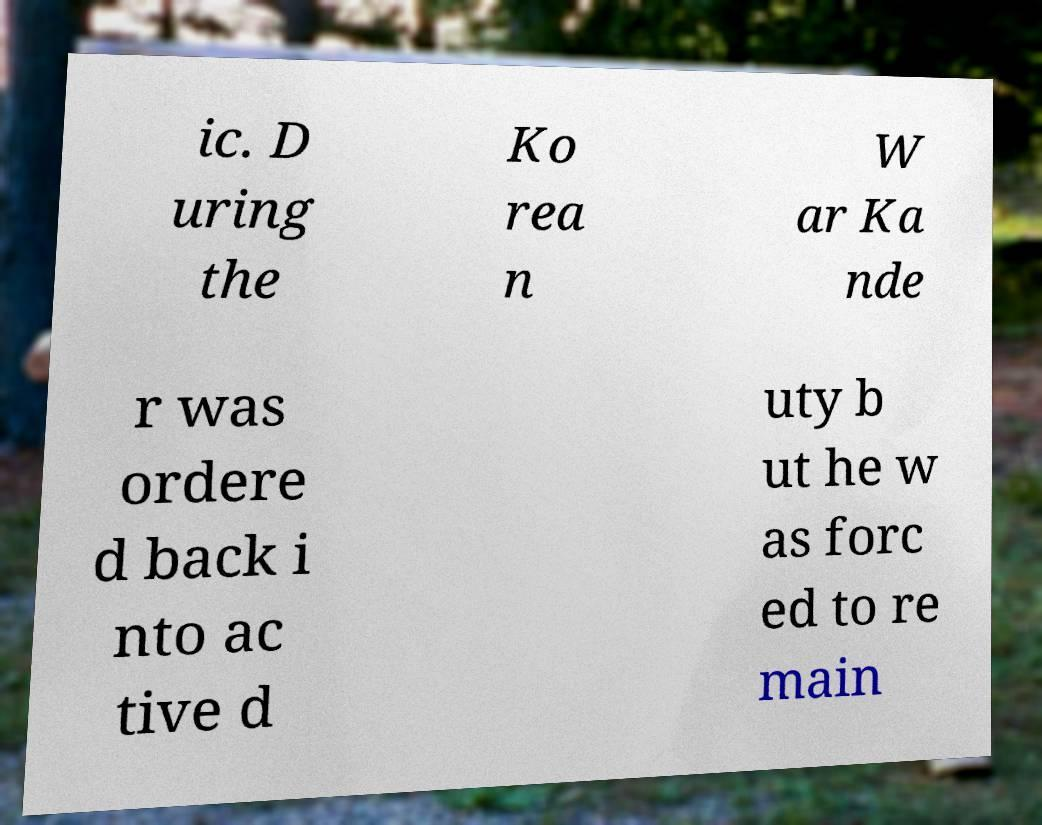Can you read and provide the text displayed in the image?This photo seems to have some interesting text. Can you extract and type it out for me? ic. D uring the Ko rea n W ar Ka nde r was ordere d back i nto ac tive d uty b ut he w as forc ed to re main 